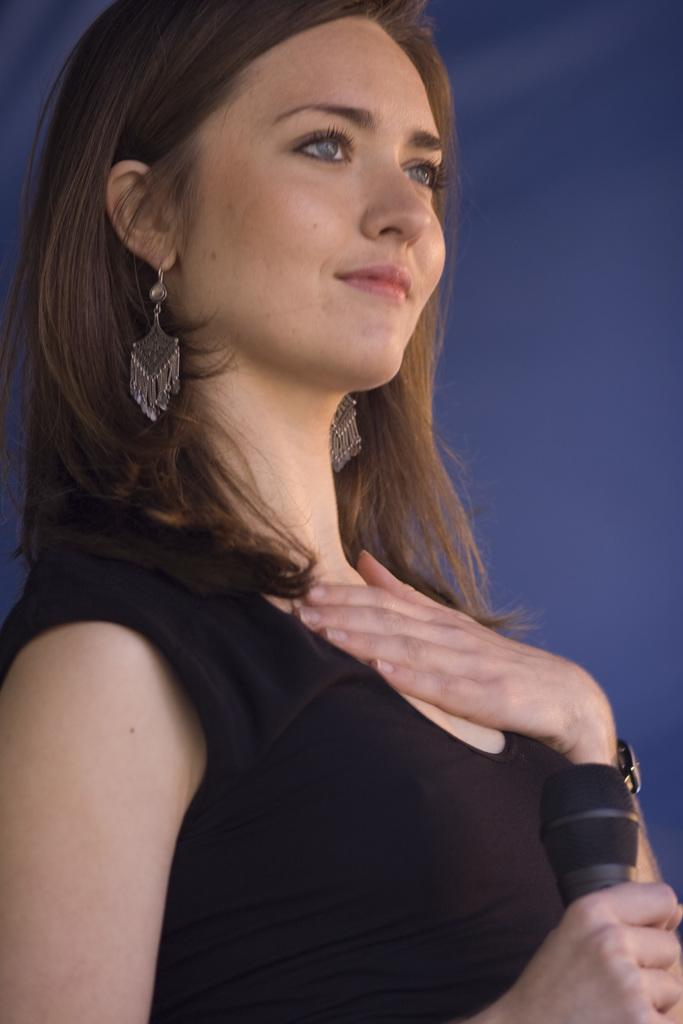Who is the main subject in the image? There is a woman in the image. What is the woman wearing? The woman is wearing a black dress. What is the woman holding in the image? The woman is holding a microphone. Can you describe the woman's earrings? The woman is wearing earrings with a design. What type of pencil can be seen in the woman's hand in the image? There is no pencil present in the woman's hand in the image. 